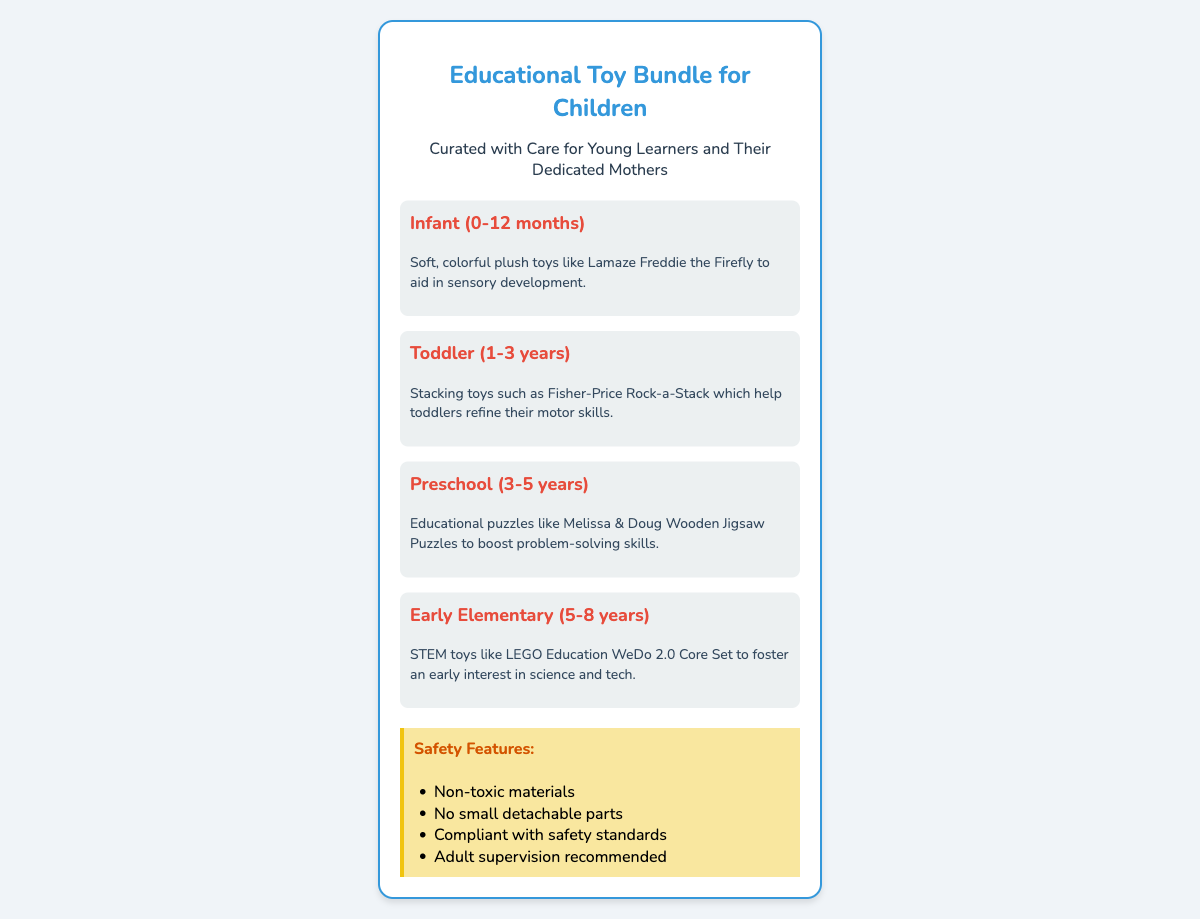what is the age range for the Infant toy category? The age range for the Infant category is specified in the document as 0-12 months.
Answer: 0-12 months what type of toy is featured for Toddlers? The specific type of toy for Toddlers mentioned in the document is stacking toys.
Answer: Stacking toys which brand of puzzle is included in the Preschool category? The brand of puzzle included in the Preschool category is Melissa & Doug.
Answer: Melissa & Doug how many safety features are listed in the document? The document lists four safety features under the Safety Features section.
Answer: Four what is the primary focus of STEM toys in the Early Elementary category? The primary focus of STEM toys in the Early Elementary category is to foster an early interest in science and tech.
Answer: Science and tech what is the color used in the header for the shipping label? The specific color used in the header for the shipping label is blue, highlighted in the title styling.
Answer: Blue what is recommended alongside the toys regarding supervision? The document recommends adult supervision alongside the toys regarding their use.
Answer: Adult supervision what is the purpose of the Educational Toy Bundle as stated in the label? The purpose of the Educational Toy Bundle is curated with care for young learners and their dedicated mothers.
Answer: Curated with care for young learners and their dedicated mothers 